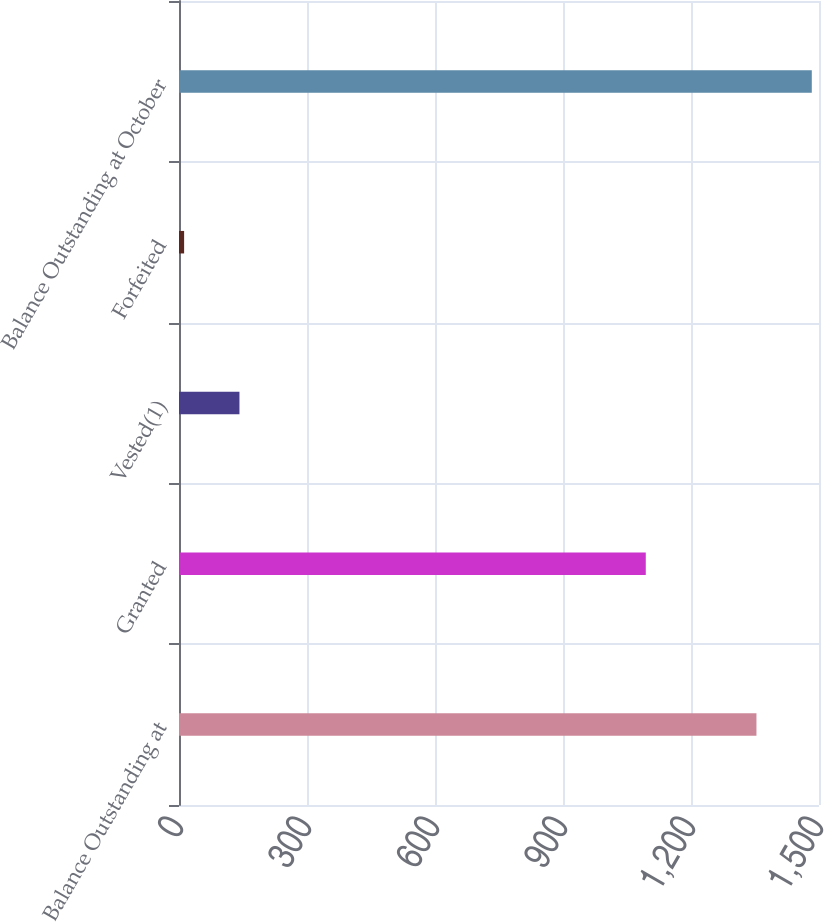Convert chart. <chart><loc_0><loc_0><loc_500><loc_500><bar_chart><fcel>Balance Outstanding at<fcel>Granted<fcel>Vested(1)<fcel>Forfeited<fcel>Balance Outstanding at October<nl><fcel>1353.4<fcel>1094<fcel>141.7<fcel>12<fcel>1483.1<nl></chart> 